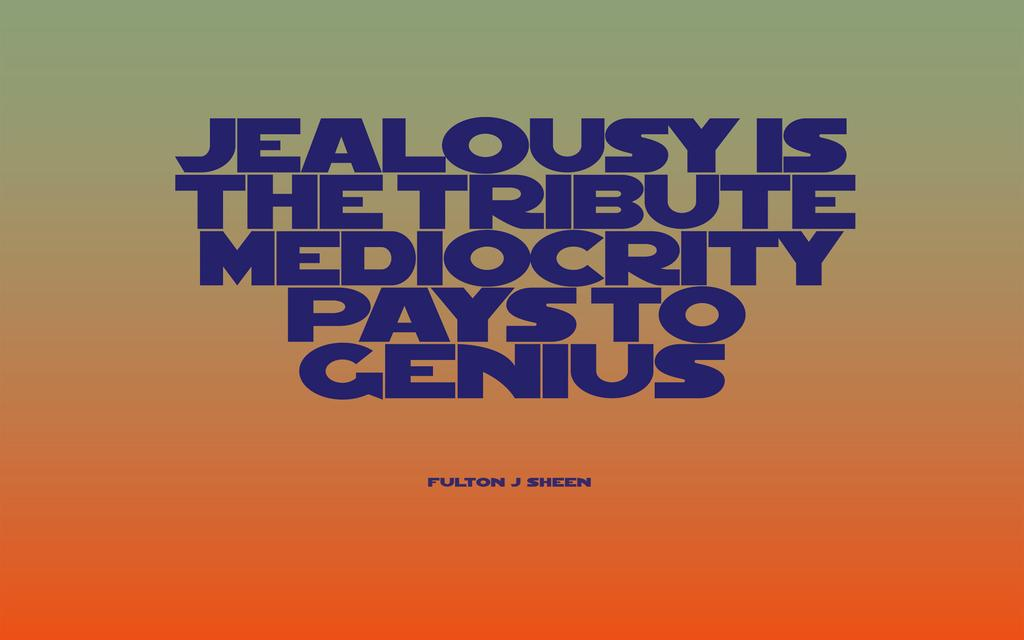<image>
Provide a brief description of the given image. A digital quote written by Fulton J. Sheen 